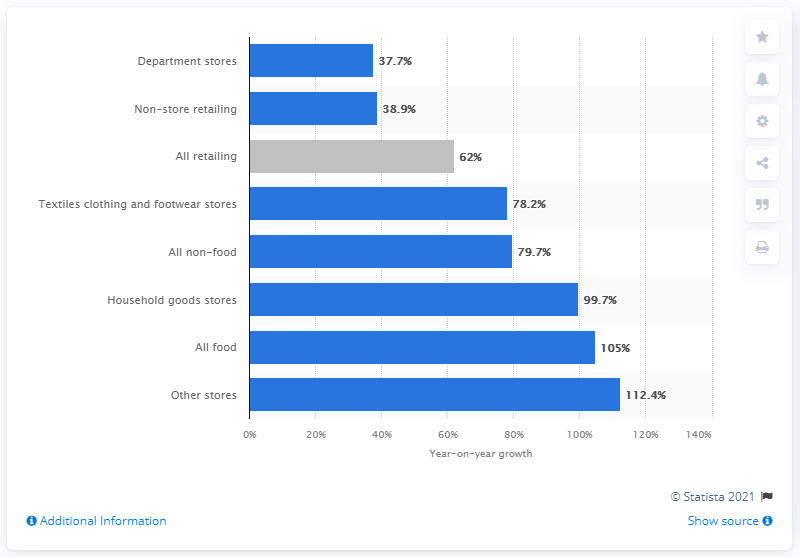Draw attention to some important aspects in this diagram. As of March 2021, online sales in food retail have grown by 105%. 